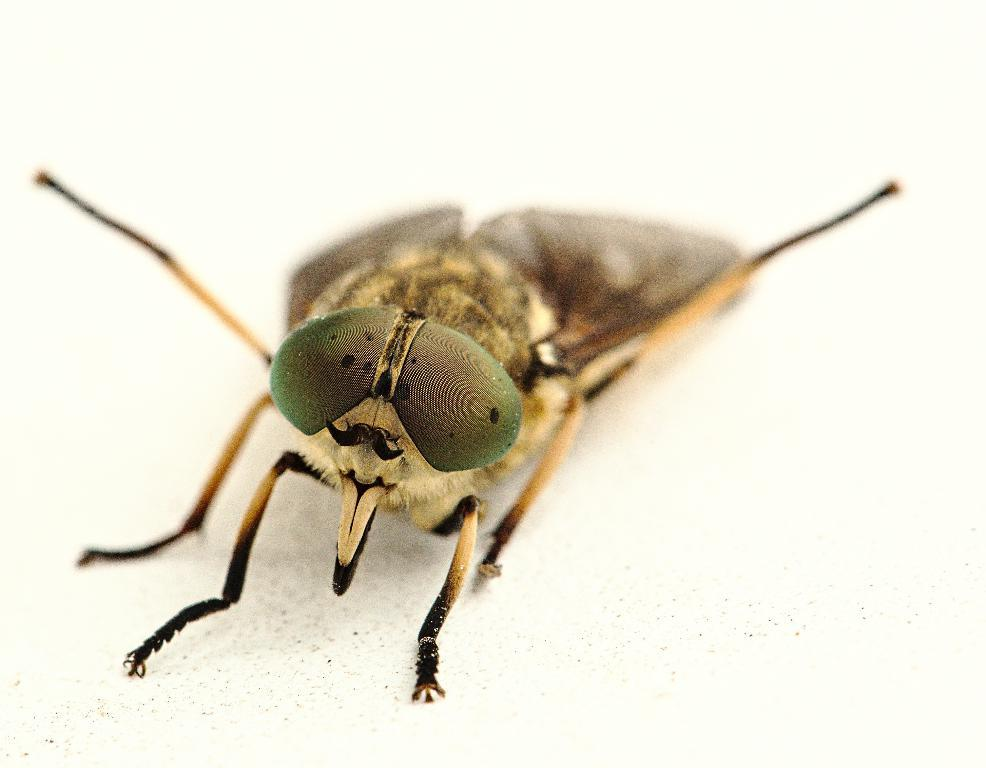What type of creature is present in the image? There is an insect in the image. What is the color of the insect? The insect is brown in color. What color are the insect's eyes? The insect's eyes are green. What type of clothing is the scarecrow wearing in the image? There is no scarecrow present in the image; it features an insect. What fact can be learned about the hot temperature in the image? There is no information about temperature in the image; it only describes the insect's appearance. 